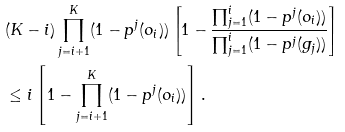<formula> <loc_0><loc_0><loc_500><loc_500>& ( K - i ) \prod _ { j = i + 1 } ^ { K } ( 1 - p ^ { j } ( o _ { i } ) ) \left [ 1 - \frac { \prod _ { j = 1 } ^ { i } ( 1 - p ^ { j } ( o _ { i } ) ) } { \prod _ { j = 1 } ^ { i } ( 1 - p ^ { j } ( g _ { j } ) ) } \right ] \\ & \leq i \left [ 1 - \prod _ { j = i + 1 } ^ { K } ( 1 - p ^ { j } ( o _ { i } ) ) \right ] .</formula> 